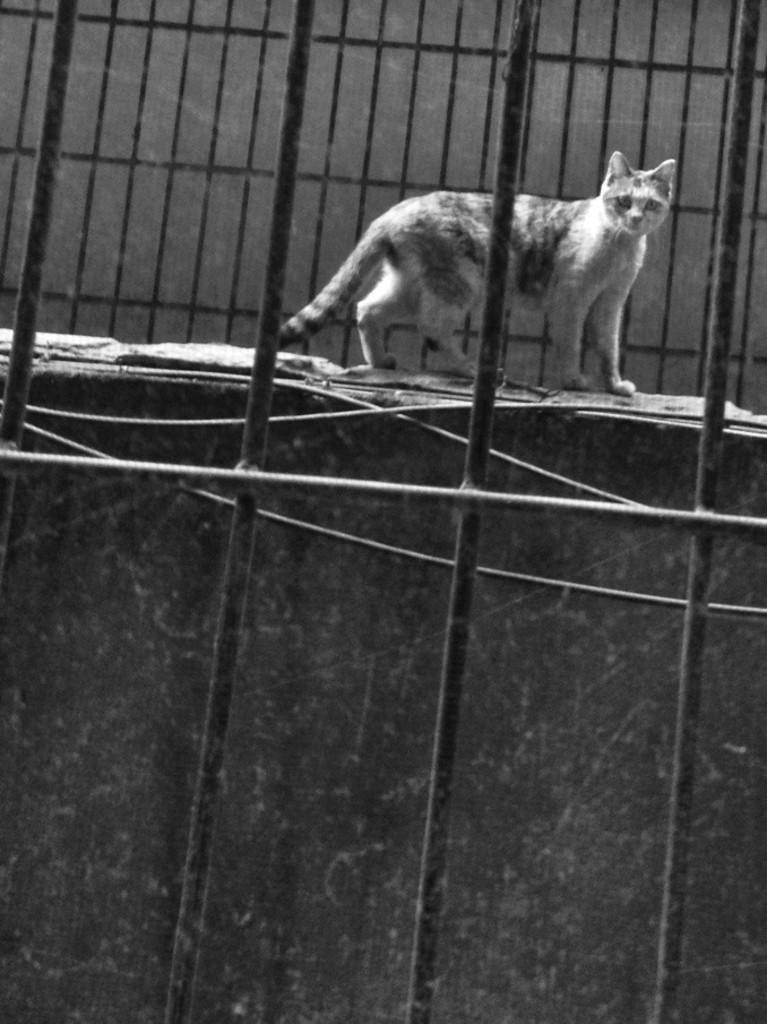What animal is present in the image? There is a cat in the picture. What is the cat doing in the image? The cat is walking on a wall. What type of barrier surrounds the wall? There is a fence around the wall. What type of balls can be seen rolling on the wall in the image? There are no balls present in the image; it features a cat walking on a wall with a fence surrounding it. 